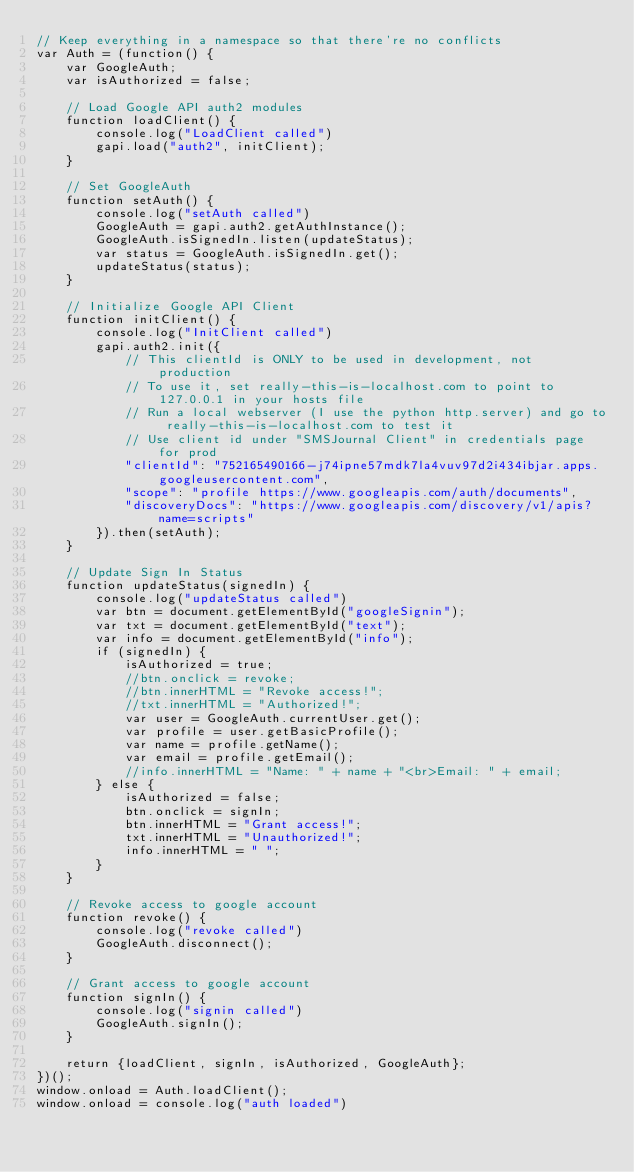Convert code to text. <code><loc_0><loc_0><loc_500><loc_500><_JavaScript_>// Keep everything in a namespace so that there're no conflicts
var Auth = (function() {
    var GoogleAuth;
    var isAuthorized = false;

    // Load Google API auth2 modules
    function loadClient() {
        console.log("LoadClient called")
        gapi.load("auth2", initClient);
    }

    // Set GoogleAuth
    function setAuth() {
        console.log("setAuth called")
        GoogleAuth = gapi.auth2.getAuthInstance();
        GoogleAuth.isSignedIn.listen(updateStatus);
        var status = GoogleAuth.isSignedIn.get();
        updateStatus(status);
    }

    // Initialize Google API Client
    function initClient() {
        console.log("InitClient called")
        gapi.auth2.init({
            // This clientId is ONLY to be used in development, not production
            // To use it, set really-this-is-localhost.com to point to 127.0.0.1 in your hosts file
            // Run a local webserver (I use the python http.server) and go to really-this-is-localhost.com to test it
            // Use client id under "SMSJournal Client" in credentials page for prod
            "clientId": "752165490166-j74ipne57mdk7la4vuv97d2i434ibjar.apps.googleusercontent.com",
            "scope": "profile https://www.googleapis.com/auth/documents",
            "discoveryDocs": "https://www.googleapis.com/discovery/v1/apis?name=scripts"
        }).then(setAuth);
    }

    // Update Sign In Status
    function updateStatus(signedIn) {
        console.log("updateStatus called")
        var btn = document.getElementById("googleSignin");
        var txt = document.getElementById("text");
        var info = document.getElementById("info");
        if (signedIn) {
            isAuthorized = true;
            //btn.onclick = revoke;
            //btn.innerHTML = "Revoke access!";
            //txt.innerHTML = "Authorized!";
            var user = GoogleAuth.currentUser.get();
            var profile = user.getBasicProfile();
            var name = profile.getName();
            var email = profile.getEmail();
            //info.innerHTML = "Name: " + name + "<br>Email: " + email;
        } else {
            isAuthorized = false;
            btn.onclick = signIn;
            btn.innerHTML = "Grant access!";
            txt.innerHTML = "Unauthorized!";
            info.innerHTML = " ";
        }
    }

    // Revoke access to google account
    function revoke() {
        console.log("revoke called")
        GoogleAuth.disconnect();
    }

    // Grant access to google account
    function signIn() {
        console.log("signin called")
        GoogleAuth.signIn();
    }

    return {loadClient, signIn, isAuthorized, GoogleAuth};
})();
window.onload = Auth.loadClient();
window.onload = console.log("auth loaded")
</code> 